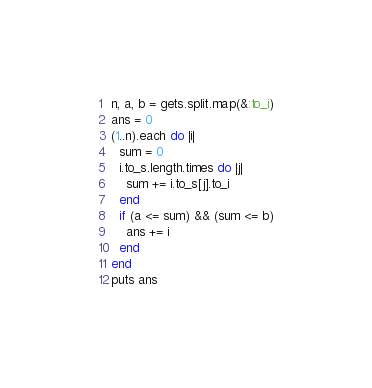<code> <loc_0><loc_0><loc_500><loc_500><_Ruby_>n, a, b = gets.split.map(&:to_i)
ans = 0
(1..n).each do |i|
  sum = 0
  i.to_s.length.times do |j|
    sum += i.to_s[j].to_i
  end
  if (a <= sum) && (sum <= b)
    ans += i
  end
end
puts ans</code> 